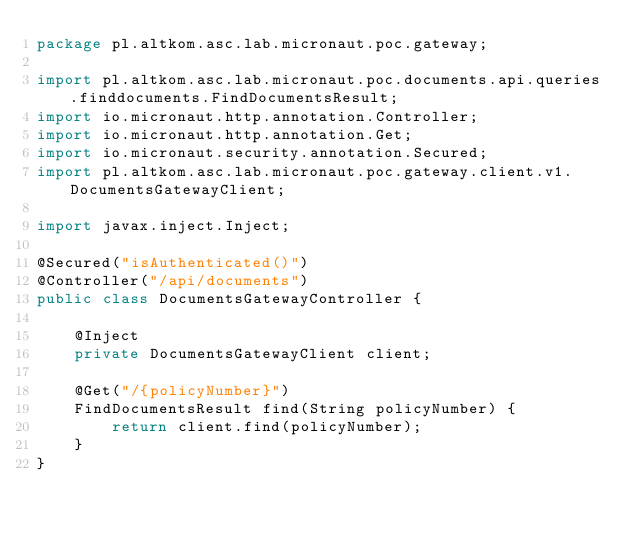<code> <loc_0><loc_0><loc_500><loc_500><_Java_>package pl.altkom.asc.lab.micronaut.poc.gateway;

import pl.altkom.asc.lab.micronaut.poc.documents.api.queries.finddocuments.FindDocumentsResult;
import io.micronaut.http.annotation.Controller;
import io.micronaut.http.annotation.Get;
import io.micronaut.security.annotation.Secured;
import pl.altkom.asc.lab.micronaut.poc.gateway.client.v1.DocumentsGatewayClient;

import javax.inject.Inject;

@Secured("isAuthenticated()")
@Controller("/api/documents")
public class DocumentsGatewayController {

    @Inject
    private DocumentsGatewayClient client;

    @Get("/{policyNumber}")
    FindDocumentsResult find(String policyNumber) {
        return client.find(policyNumber);
    }
}

</code> 